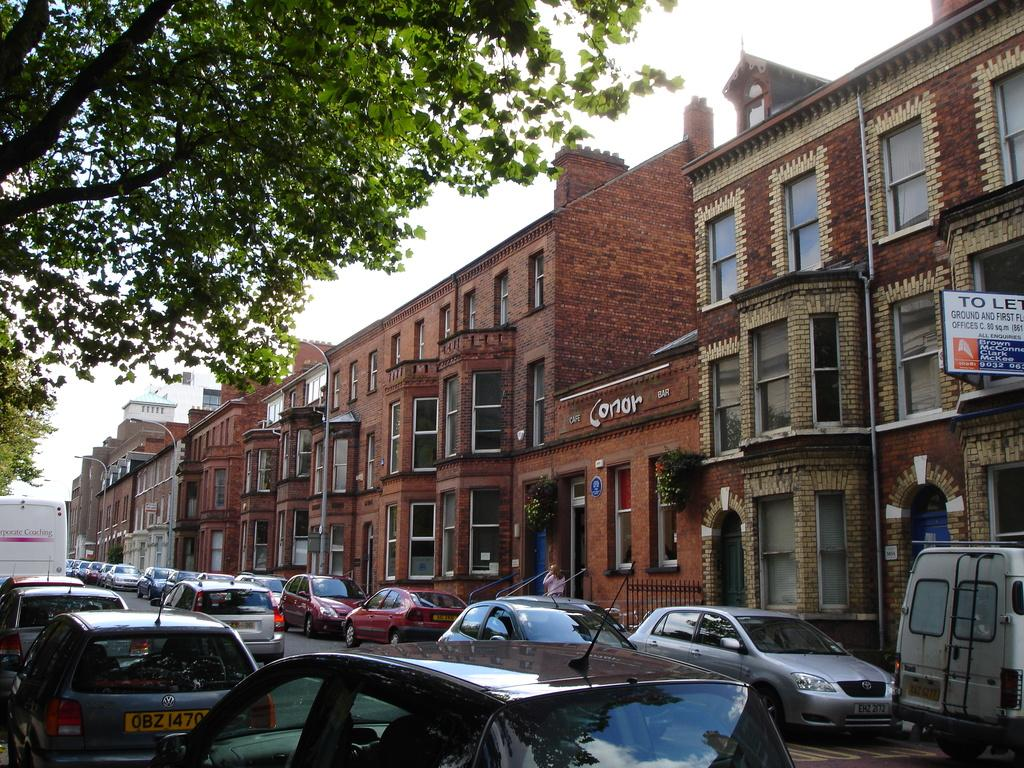Provide a one-sentence caption for the provided image. Short building named Cafe Conor Bar in between a row of other buildings. 